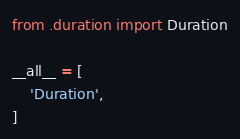<code> <loc_0><loc_0><loc_500><loc_500><_Python_>from .duration import Duration

__all__ = [
    'Duration',
]
</code> 